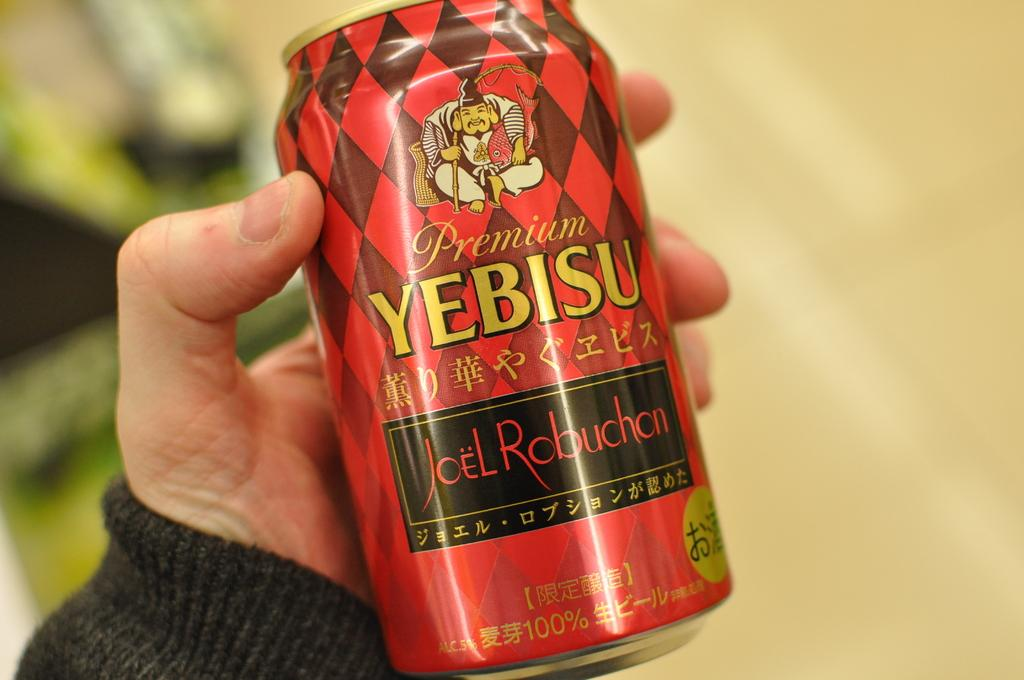<image>
Render a clear and concise summary of the photo. a Yebisu can in the person's hand in front of them 